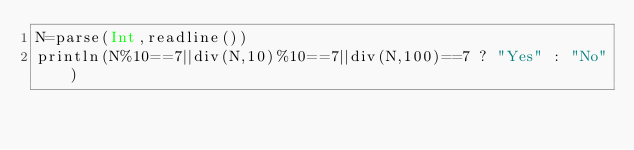Convert code to text. <code><loc_0><loc_0><loc_500><loc_500><_Julia_>N=parse(Int,readline())
println(N%10==7||div(N,10)%10==7||div(N,100)==7 ? "Yes" : "No")</code> 